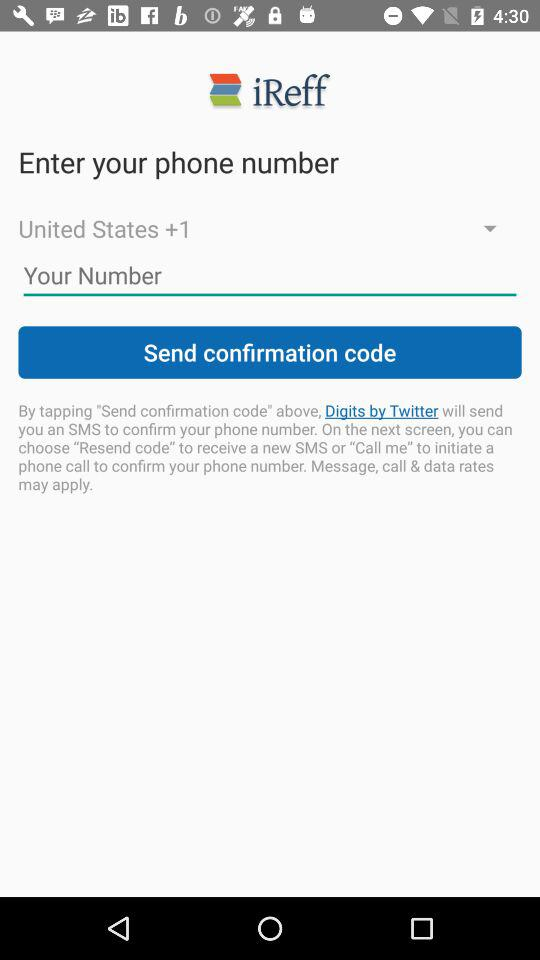What is the app name? The app name is "iReff". 